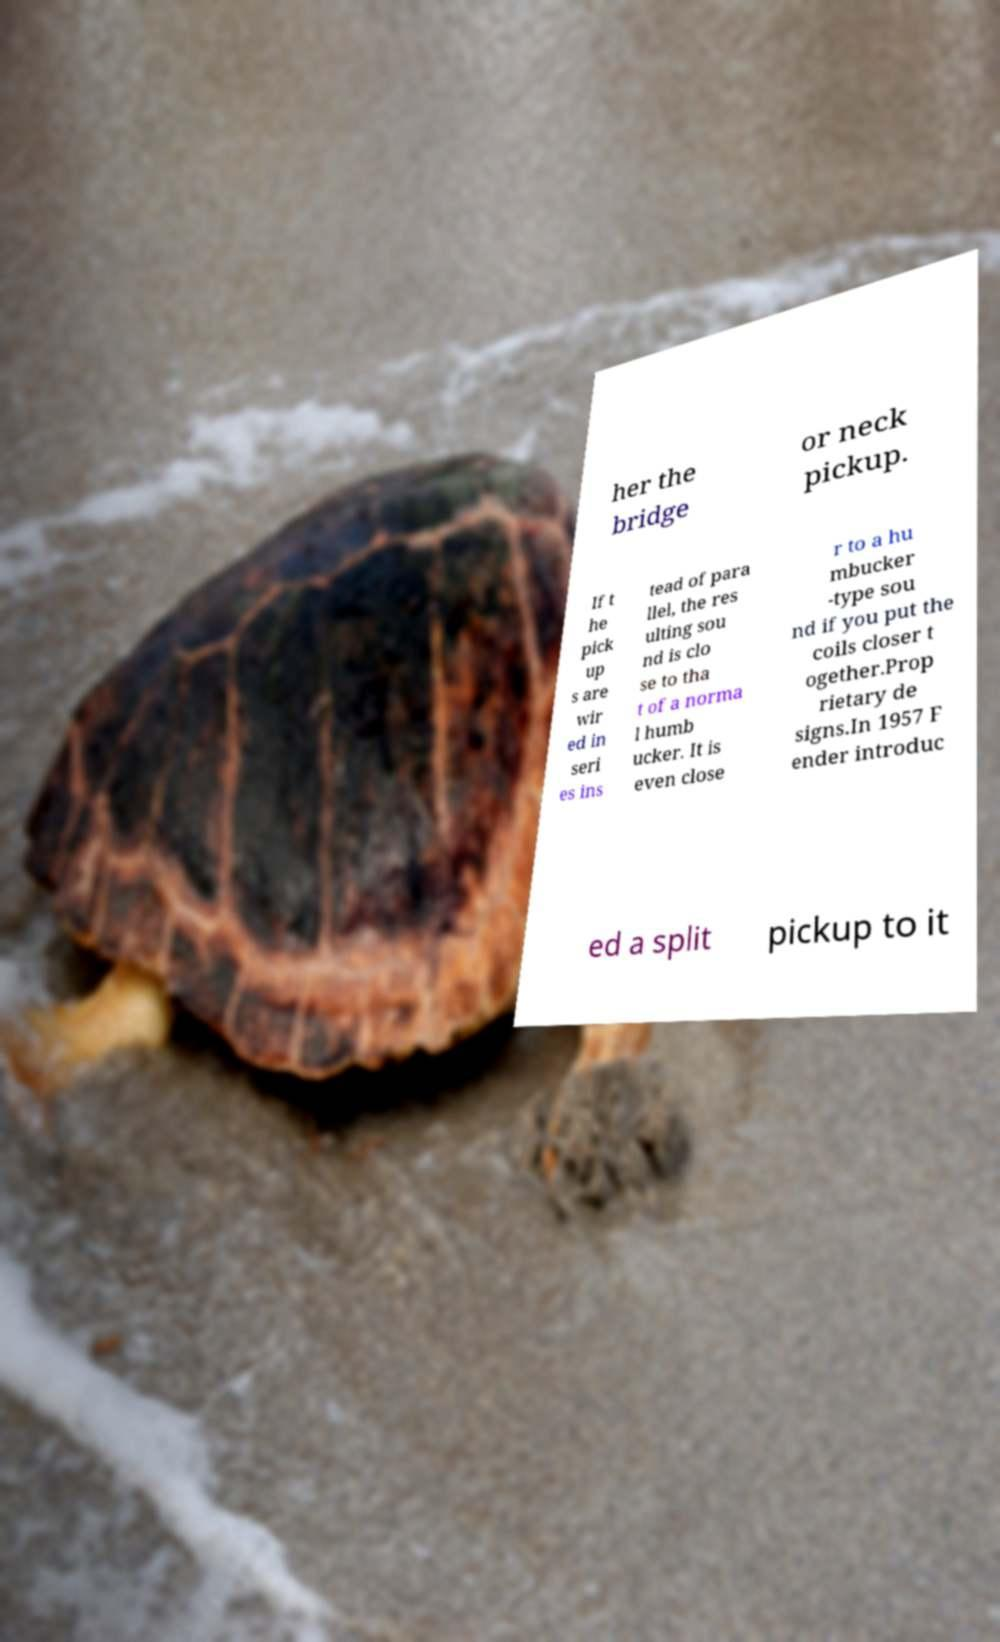Could you extract and type out the text from this image? her the bridge or neck pickup. If t he pick up s are wir ed in seri es ins tead of para llel, the res ulting sou nd is clo se to tha t of a norma l humb ucker. It is even close r to a hu mbucker -type sou nd if you put the coils closer t ogether.Prop rietary de signs.In 1957 F ender introduc ed a split pickup to it 